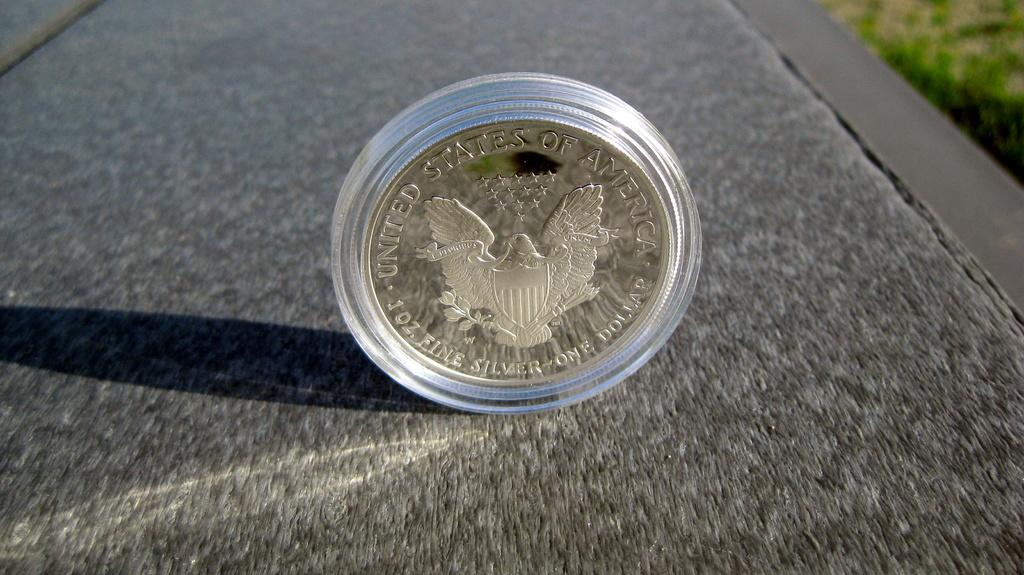Provide a one-sentence caption for the provided image. A coin with United States Silver one dollar on it. 